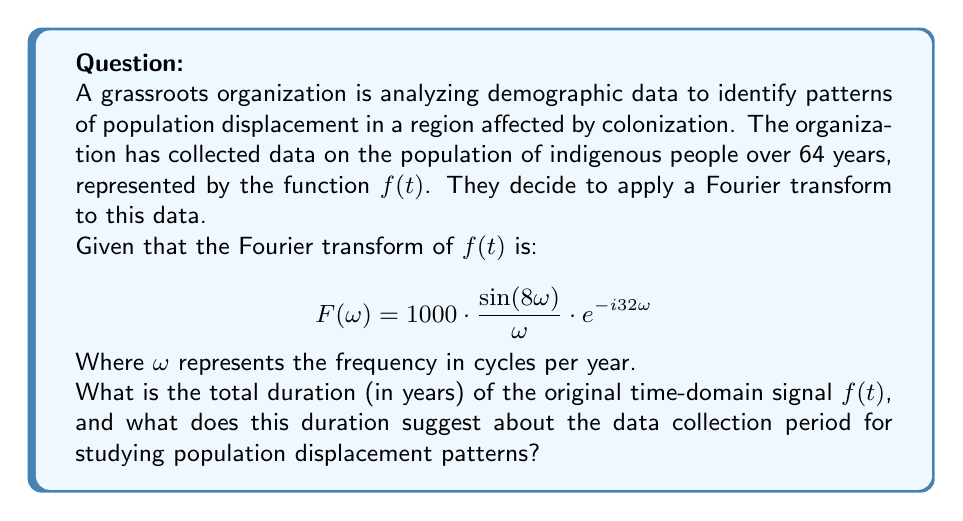Teach me how to tackle this problem. To solve this problem, we need to analyze the given Fourier transform equation:

$$F(\omega) = 1000 \cdot \frac{\sin(8\omega)}{\omega} \cdot e^{-i32\omega}$$

1) First, let's identify the key components of this equation:
   - The $\frac{\sin(8\omega)}{\omega}$ term is a sinc function
   - The $e^{-i32\omega}$ term represents a time shift

2) The sinc function $\frac{\sin(a\omega)}{\omega}$ is the Fourier transform of a rectangular function with width $2a$ in the time domain.

3) In our case, $a = 8$, so the width of the rectangular function in the time domain is $2 * 8 = 16$ years.

4) The $e^{-i32\omega}$ term represents a time shift of 32 years. This means the center of our rectangular function is at t = 32 years.

5) To find the total duration, we need to consider both the width of the rectangular function and its position:
   - The function starts at: 32 - 16/2 = 24 years
   - The function ends at: 32 + 16/2 = 40 years

6) Therefore, the total duration is: 40 - 24 = 16 years

7) However, we're told that the data is collected over 64 years. This suggests that the actual data collection period is 4 times longer than the effective duration captured by this Fourier transform.

This duration suggests that the data collection period for studying population displacement patterns spans 64 years, allowing for a comprehensive long-term analysis of demographic changes due to colonization impacts.
Answer: 16 years (effective duration); 64 years (total data collection period) 